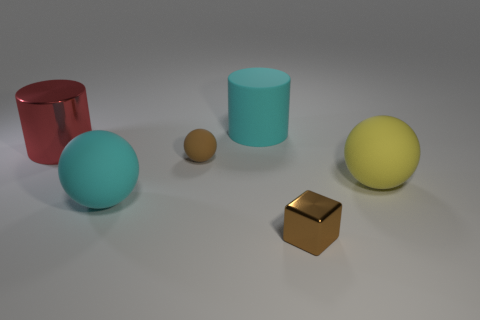Add 1 shiny cylinders. How many objects exist? 7 Subtract all cubes. How many objects are left? 5 Add 5 big yellow spheres. How many big yellow spheres exist? 6 Subtract 0 gray spheres. How many objects are left? 6 Subtract all shiny spheres. Subtract all big shiny cylinders. How many objects are left? 5 Add 4 large red things. How many large red things are left? 5 